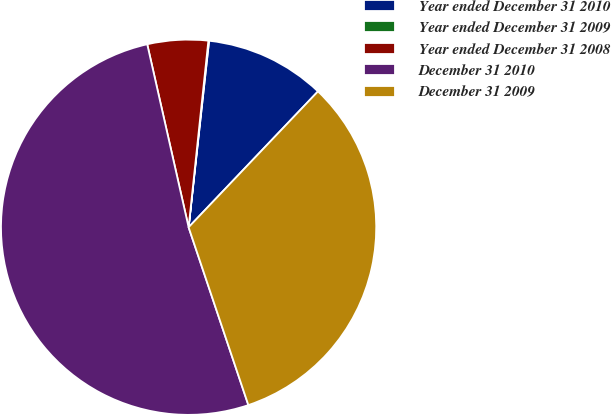Convert chart to OTSL. <chart><loc_0><loc_0><loc_500><loc_500><pie_chart><fcel>Year ended December 31 2010<fcel>Year ended December 31 2009<fcel>Year ended December 31 2008<fcel>December 31 2010<fcel>December 31 2009<nl><fcel>10.37%<fcel>0.06%<fcel>5.22%<fcel>51.62%<fcel>32.73%<nl></chart> 